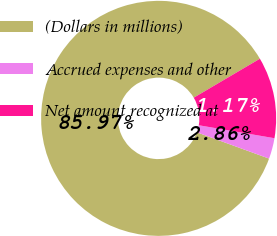Convert chart to OTSL. <chart><loc_0><loc_0><loc_500><loc_500><pie_chart><fcel>(Dollars in millions)<fcel>Accrued expenses and other<fcel>Net amount recognized at<nl><fcel>85.96%<fcel>2.86%<fcel>11.17%<nl></chart> 